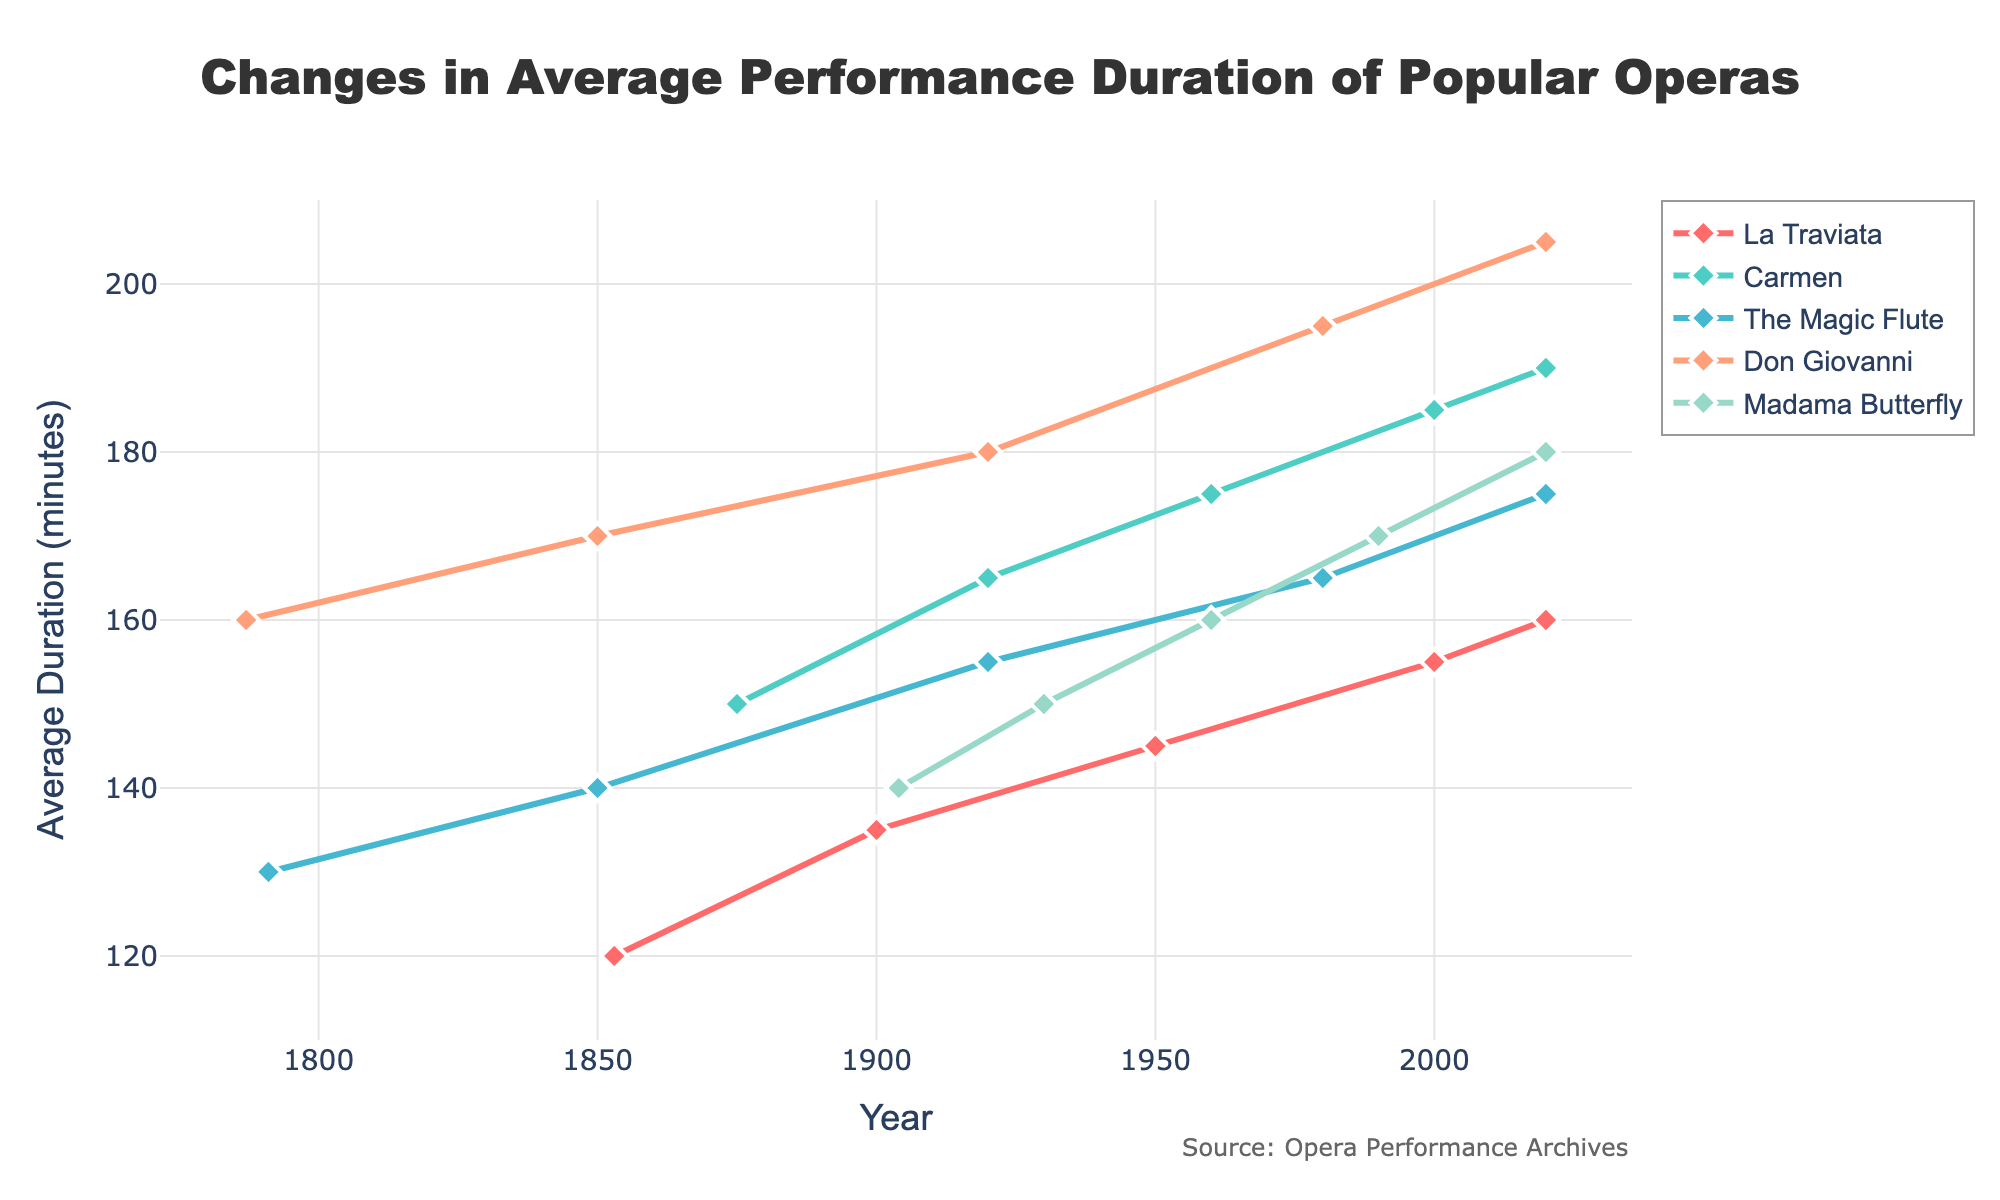What's the trend in the average performance duration of "La Traviata" from 1853 to 2020? The line chart shows the duration of "La Traviata" increasing from approximately 120 minutes in 1853 to about 160 minutes in 2020, indicating a general upward trend over the years.
Answer: Upward trend Which opera has the longest average performance duration in 2020? By looking at the line chart for the year 2020, "Don Giovanni" has the longest duration of 205 minutes.
Answer: Don Giovanni What's the difference in average performance duration of "Carmen" between its premiere and 2020? To find the difference, subtract the average duration at the premiere in 1875 (150 minutes) from the duration in 2020 (190 minutes): 190 - 150 = 40 minutes.
Answer: 40 minutes How do "The Magic Flute" and "Madama Butterfly" compare in terms of their average performance duration in 1980? In 1980, "The Magic Flute" has an average duration of 165 minutes, while "Madama Butterfly" is not represented in the chart for this year, indicating no comparison can be made for that specific year.
Answer: No comparison for that year Which opera shows the most significant increase in performance duration from its premiere to 2020 based on the visual cues of the line lengths? By observing the slopes and differences in line lengths from premieres to 2020, "Don Giovanni" shows the most significant increase from 160 to 205 minutes.
Answer: Don Giovanni What’s the average duration of "Carmen," "The Magic Flute," and "Madama Butterfly" in 2020? Add the 2020 durations: "Carmen" (190) + "The Magic Flute" (175) + "Madama Butterfly" (180) = 545. The average is 545/3 = 181.67 minutes.
Answer: 181.67 minutes In which year do "La Traviata" and "Don Giovanni" intersect in terms of average performance duration? By examining the chart, the lines for "La Traviata" and "Don Giovanni" never intersect at the same duration value.
Answer: Never intersect What is the total change in duration for "The Magic Flute" from 1791 to 2020? Subtract the initial duration in 1791 (130 minutes) from the duration in 2020 (175 minutes): 175 - 130 = 45 minutes.
Answer: 45 minutes 